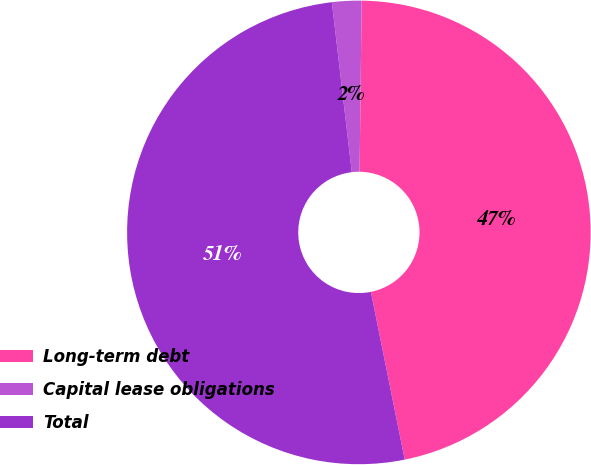Convert chart to OTSL. <chart><loc_0><loc_0><loc_500><loc_500><pie_chart><fcel>Long-term debt<fcel>Capital lease obligations<fcel>Total<nl><fcel>46.64%<fcel>2.05%<fcel>51.31%<nl></chart> 